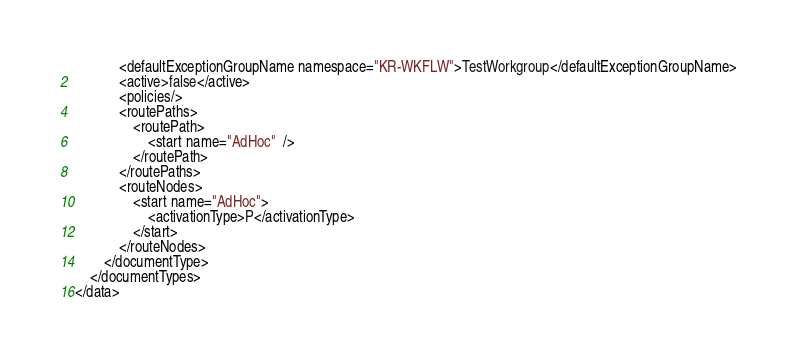Convert code to text. <code><loc_0><loc_0><loc_500><loc_500><_XML_>			<defaultExceptionGroupName namespace="KR-WKFLW">TestWorkgroup</defaultExceptionGroupName>
			<active>false</active>
			<policies/>
			<routePaths>
				<routePath>
					<start name="AdHoc"  />
				</routePath>
			</routePaths>
			<routeNodes>
				<start name="AdHoc">
					<activationType>P</activationType>
				</start>
			</routeNodes>
		</documentType>
	</documentTypes>
</data>
</code> 